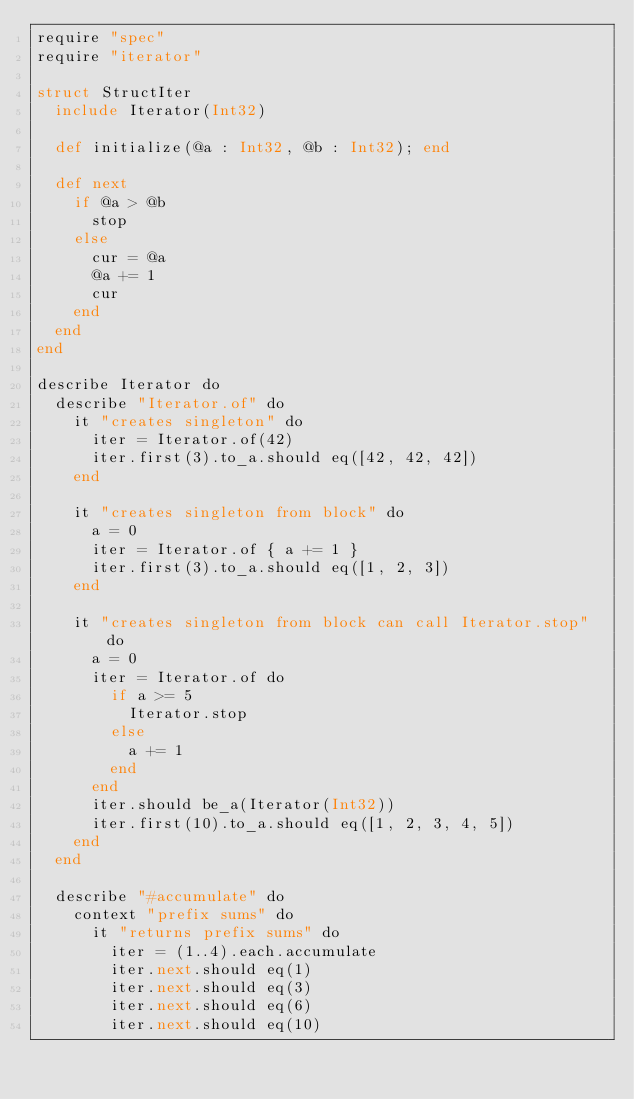<code> <loc_0><loc_0><loc_500><loc_500><_Crystal_>require "spec"
require "iterator"

struct StructIter
  include Iterator(Int32)

  def initialize(@a : Int32, @b : Int32); end

  def next
    if @a > @b
      stop
    else
      cur = @a
      @a += 1
      cur
    end
  end
end

describe Iterator do
  describe "Iterator.of" do
    it "creates singleton" do
      iter = Iterator.of(42)
      iter.first(3).to_a.should eq([42, 42, 42])
    end

    it "creates singleton from block" do
      a = 0
      iter = Iterator.of { a += 1 }
      iter.first(3).to_a.should eq([1, 2, 3])
    end

    it "creates singleton from block can call Iterator.stop" do
      a = 0
      iter = Iterator.of do
        if a >= 5
          Iterator.stop
        else
          a += 1
        end
      end
      iter.should be_a(Iterator(Int32))
      iter.first(10).to_a.should eq([1, 2, 3, 4, 5])
    end
  end

  describe "#accumulate" do
    context "prefix sums" do
      it "returns prefix sums" do
        iter = (1..4).each.accumulate
        iter.next.should eq(1)
        iter.next.should eq(3)
        iter.next.should eq(6)
        iter.next.should eq(10)</code> 